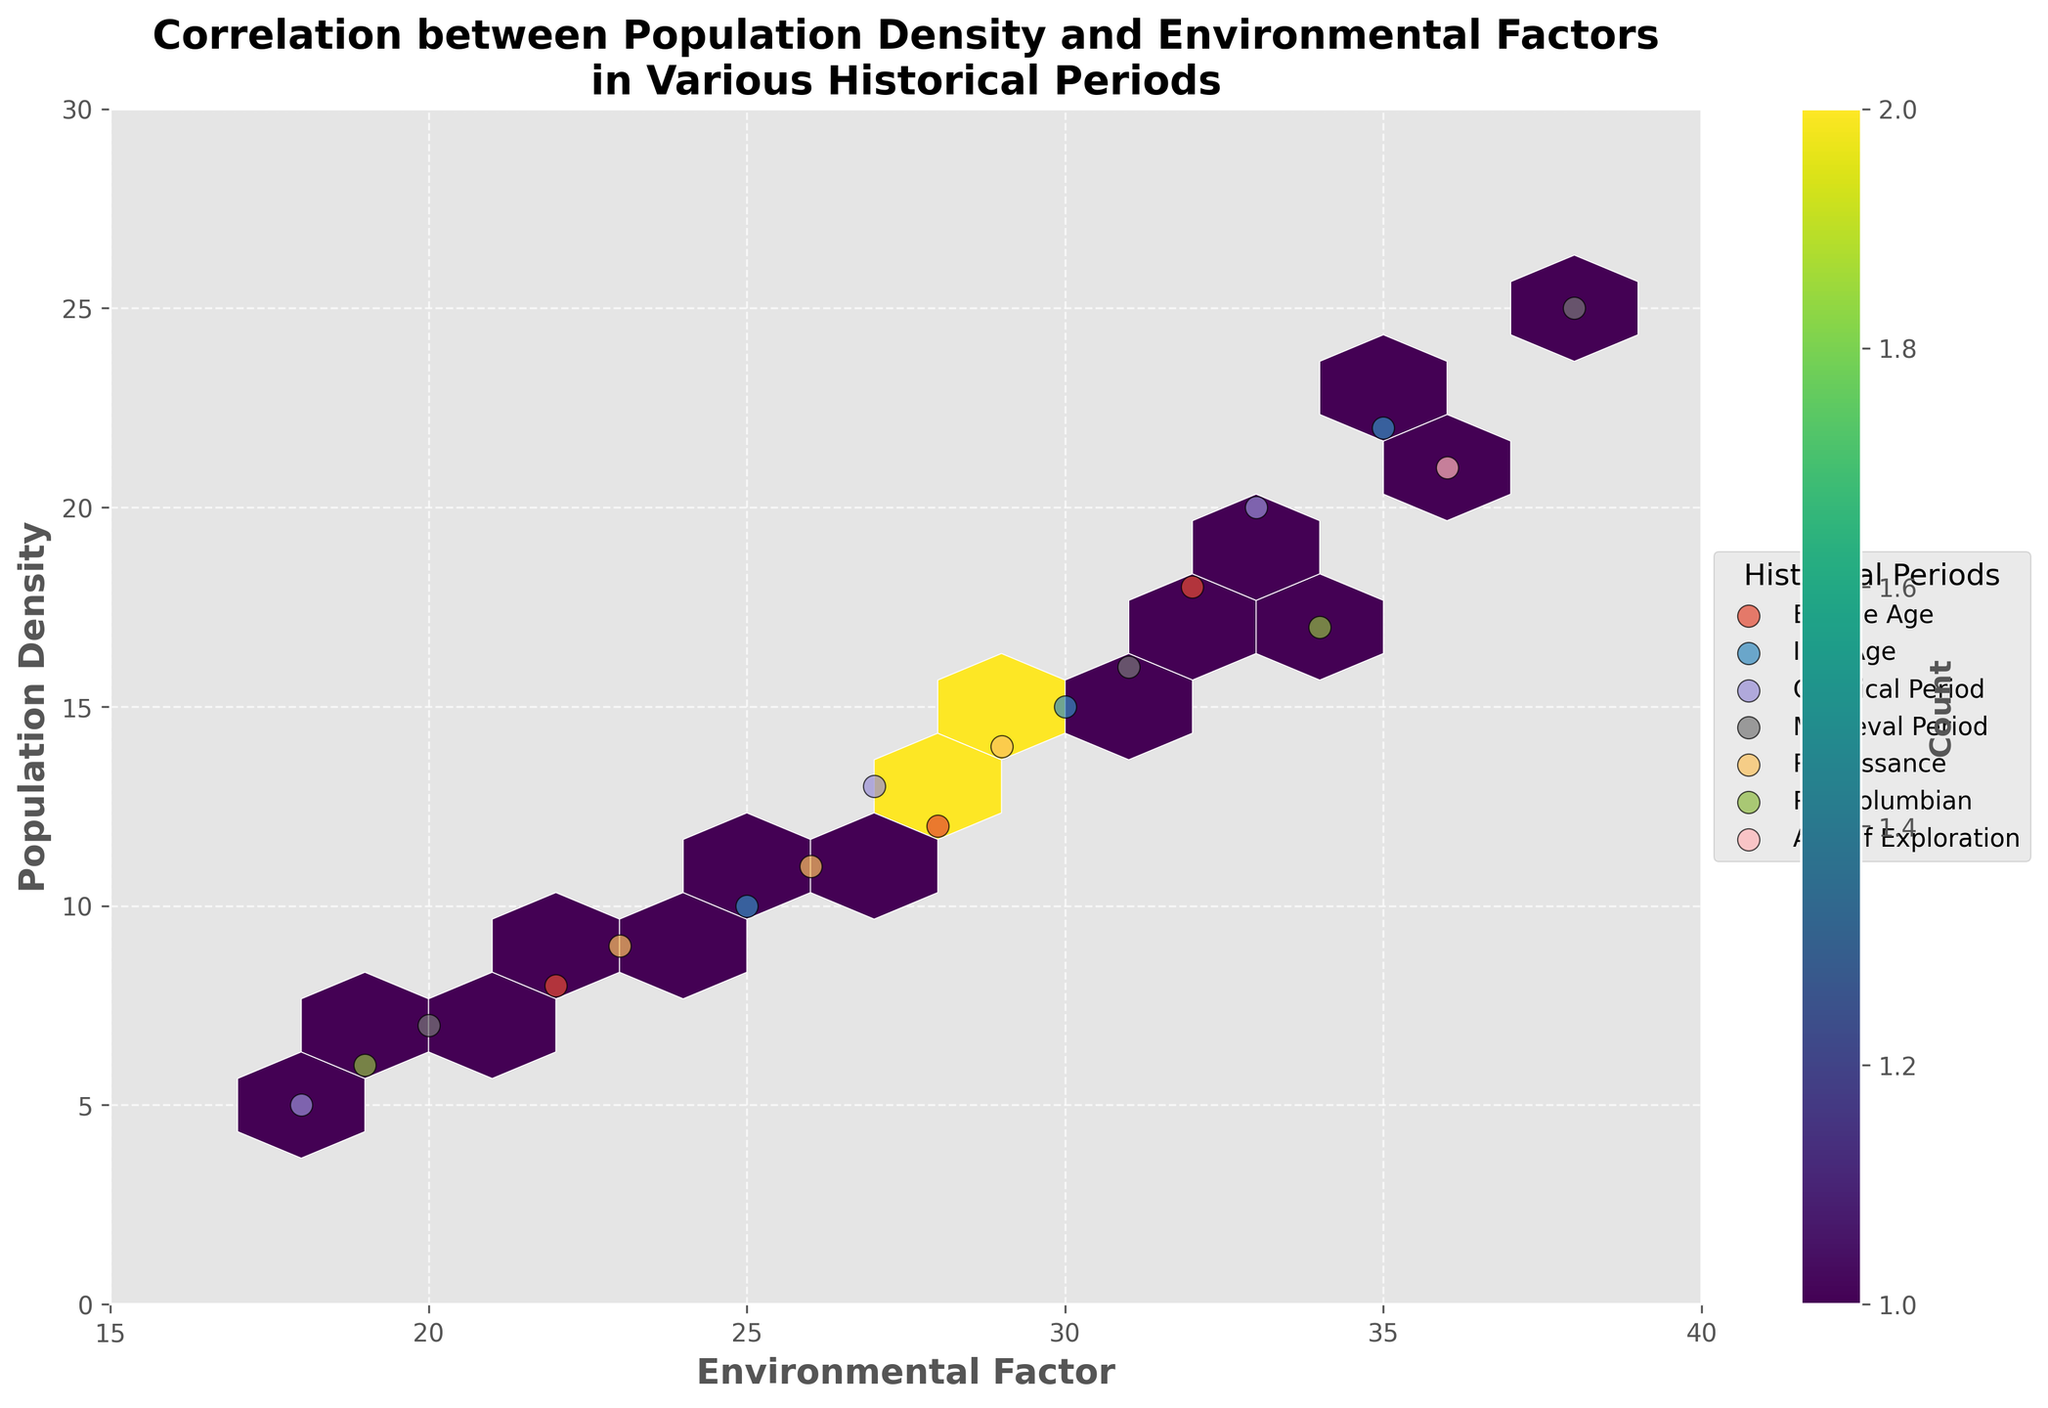What's the title of the figure? The title is shown at the top of the figure, and it reads "Correlation between Population Density and Environmental Factors in Various Historical Periods."
Answer: Correlation between Population Density and Environmental Factors in Various Historical Periods What does the x-axis represent? The label under the x-axis reads "Environmental Factor," indicating it represents environmental factors.
Answer: Environmental Factor What is the unit of color in the hexbin plot? The color bar on the right side shows the gradient and label "Count," indicating the color represents the count of data points falling within each hexagon.
Answer: Count Which historical period has the highest population density? To determine this, observe the legend for each period's points and look for the highest point on the y-axis. The Medieval Period has a population density of 25, which is the highest observed.
Answer: Medieval Period Is there a visible correlation between population density and environmental factors? The figure shows a positive correlation between population density and environmental factors, meaning as environmental factors increase, the population density tends to increase as well. This is evident from how the data points trend upward from left to right.
Answer: Yes How many periods contain data points within the environmental factor range from 25 to 30? By looking at the scatter points' horizontal spread, we can count the different markers within the 25 to 30 range on the x-axis. The periods are Bronze Age, Iron Age, Classical Period, Renaissance, and Medieval Period, totaling five periods.
Answer: 5 periods Which period has data points with the lowest environmental factor? By examining the x-axis and the scatter points, the Pre-Columbian period contains the lowest environmental factor point, around 19.
Answer: Pre-Columbian What's the range of population density for the Classical Period? By identifying the scatter points for the Classical Period, the population densities range from about 5 to 20.
Answer: 5 to 20 Which period has the largest spread in population density? The scatter points of the Medieval Period show the biggest spread on the y-axis, from 7 to 25.
Answer: Medieval Period What can be inferred about the count of data points from the color gradient in the hexbin plot? The color bar shows that darker hexagons represent higher data count. The presence of several dark hexagons indicates clusters of populations with similar density and environmental factors.
Answer: Clusters with similar density and factors 